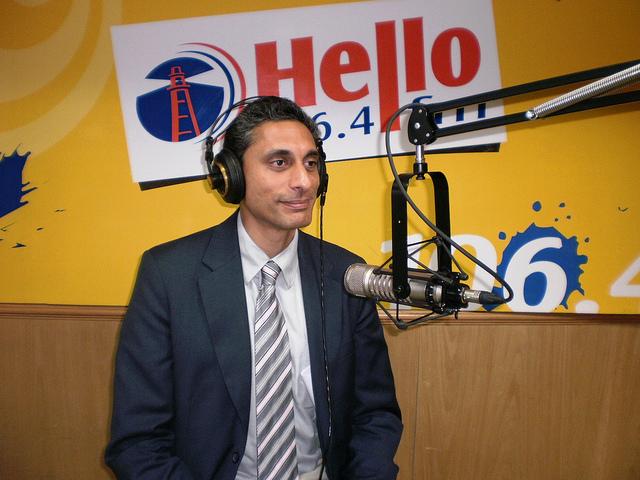What is this person's job?
Keep it brief. Radio host. Is this man a guest of the radio show or an anchor?
Give a very brief answer. Guest. Is the signs in Russian?
Answer briefly. No. What is in the red letter?
Concise answer only. Hello. What is the frequency for the station that is hosting the event?
Give a very brief answer. 106.4. 